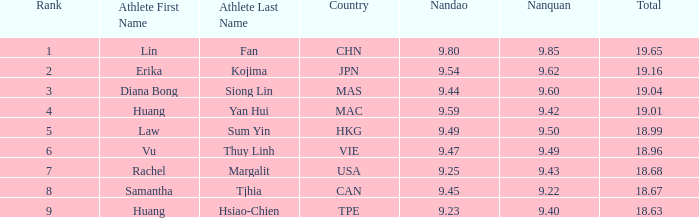Which Nanquan has a Nandao smaller than 9.44, and a Rank smaller than 9, and a Total larger than 18.68? None. 